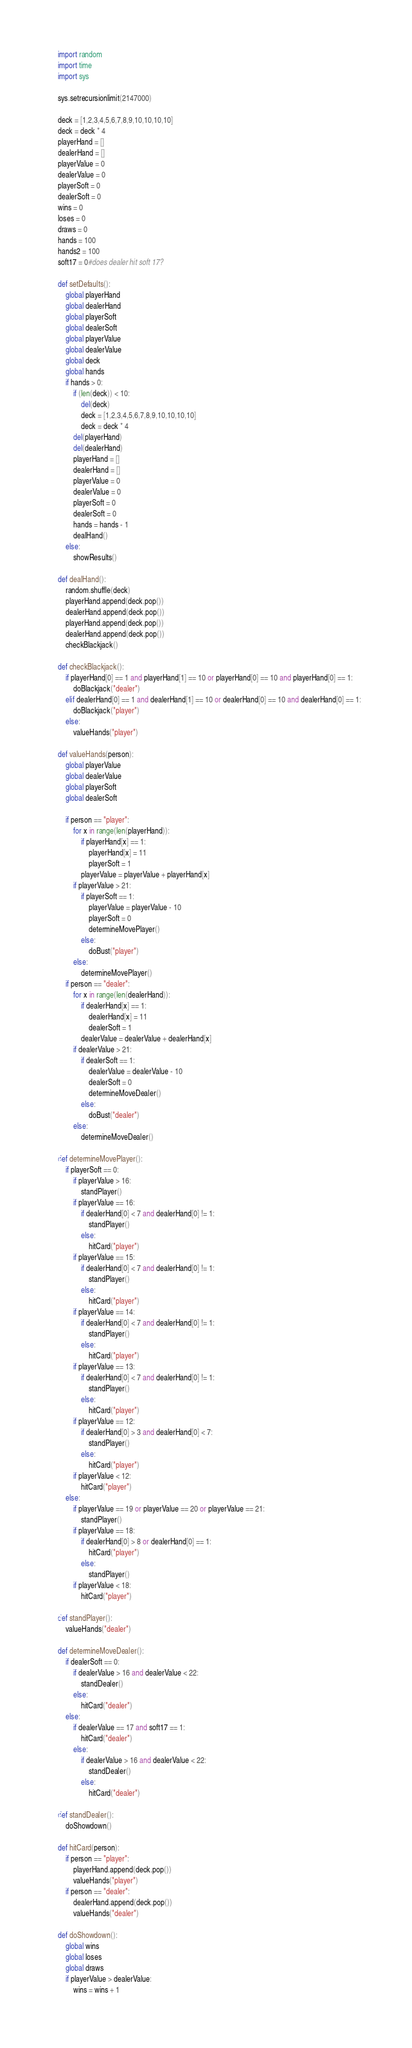<code> <loc_0><loc_0><loc_500><loc_500><_Python_>import random
import time
import sys

sys.setrecursionlimit(2147000)

deck = [1,2,3,4,5,6,7,8,9,10,10,10,10]
deck = deck * 4
playerHand = []
dealerHand = []
playerValue = 0
dealerValue = 0
playerSoft = 0
dealerSoft = 0
wins = 0
loses = 0
draws = 0
hands = 100
hands2 = 100
soft17 = 0#does dealer hit soft 17?

def setDefaults():
	global playerHand
	global dealerHand
	global playerSoft
	global dealerSoft
	global playerValue
	global dealerValue
	global deck
	global hands
	if hands > 0:
		if (len(deck)) < 10:
			del(deck)
			deck = [1,2,3,4,5,6,7,8,9,10,10,10,10]
			deck = deck * 4
		del(playerHand)
		del(dealerHand)
		playerHand = []
		dealerHand = []
		playerValue = 0
		dealerValue = 0
		playerSoft = 0
		dealerSoft = 0
		hands = hands - 1
		dealHand()
	else:
		showResults()

def dealHand():
	random.shuffle(deck)
	playerHand.append(deck.pop())
	dealerHand.append(deck.pop())
	playerHand.append(deck.pop())
	dealerHand.append(deck.pop())
	checkBlackjack()

def checkBlackjack():
	if playerHand[0] == 1 and playerHand[1] == 10 or playerHand[0] == 10 and playerHand[0] == 1:
		doBlackjack("dealer")
	elif dealerHand[0] == 1 and dealerHand[1] == 10 or dealerHand[0] == 10 and dealerHand[0] == 1:
		doBlackjack("player")
	else:
		valueHands("player")

def valueHands(person):
	global playerValue
	global dealerValue
	global playerSoft
	global dealerSoft

	if person == "player":
		for x in range(len(playerHand)):
			if playerHand[x] == 1:
				playerHand[x] = 11
				playerSoft = 1
			playerValue = playerValue + playerHand[x]
		if playerValue > 21:
			if playerSoft == 1:
				playerValue = playerValue - 10
				playerSoft = 0
				determineMovePlayer()
			else:
				doBust("player")
		else:
			determineMovePlayer()
	if person == "dealer":
		for x in range(len(dealerHand)):
			if dealerHand[x] == 1:
				dealerHand[x] = 11
				dealerSoft = 1
			dealerValue = dealerValue + dealerHand[x]
		if dealerValue > 21:
			if dealerSoft == 1:
				dealerValue = dealerValue - 10
				dealerSoft = 0
				determineMoveDealer()
			else:
				doBust("dealer")
		else:
			determineMoveDealer()

def determineMovePlayer():
	if playerSoft == 0:
		if playerValue > 16:
			standPlayer()
		if playerValue == 16:
			if dealerHand[0] < 7 and dealerHand[0] != 1:
				standPlayer()			
			else:
				hitCard("player")
		if playerValue == 15:
			if dealerHand[0] < 7 and dealerHand[0] != 1:
				standPlayer()			
			else:
				hitCard("player")
		if playerValue == 14:
			if dealerHand[0] < 7 and dealerHand[0] != 1:
				standPlayer()			
			else:
				hitCard("player")
		if playerValue == 13:
			if dealerHand[0] < 7 and dealerHand[0] != 1:
				standPlayer()			
			else:
				hitCard("player")
		if playerValue == 12:
			if dealerHand[0] > 3 and dealerHand[0] < 7:
				standPlayer()
			else:
				hitCard("player")
		if playerValue < 12:
			hitCard("player")
	else:
		if playerValue == 19 or playerValue == 20 or playerValue == 21:
			standPlayer()
		if playerValue == 18:
			if dealerHand[0] > 8 or dealerHand[0] == 1:
				hitCard("player")
			else:
				standPlayer()
		if playerValue < 18:
			hitCard("player")

def standPlayer():
	valueHands("dealer")

def determineMoveDealer():
	if dealerSoft == 0:
		if dealerValue > 16 and dealerValue < 22:
			standDealer()
		else:
			hitCard("dealer")
	else:
		if dealerValue == 17 and soft17 == 1:
			hitCard("dealer")
		else:
			if dealerValue > 16 and dealerValue < 22:
				standDealer()
			else:
				hitCard("dealer")

def standDealer(): 
	doShowdown()

def hitCard(person):
	if person == "player":
		playerHand.append(deck.pop())
		valueHands("player")
	if person == "dealer":
		dealerHand.append(deck.pop())
		valueHands("dealer")

def doShowdown():
	global wins
	global loses
	global draws
	if playerValue > dealerValue:
		wins = wins + 1</code> 